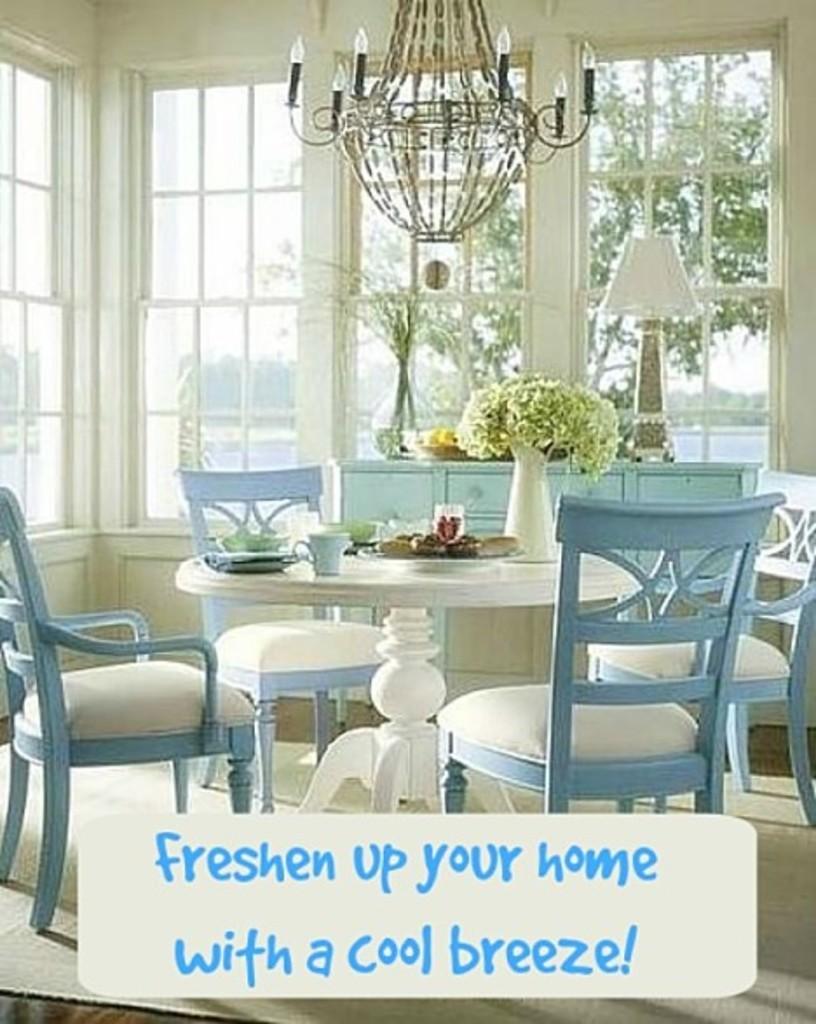Describe this image in one or two sentences. In this picture we can see blue and white color dining table in the middle of the image. Behind there is a white color glass windows and hanging chandeliers. On the front bottom side there is a small quote on the image. 